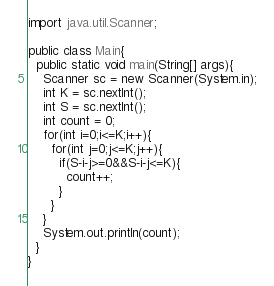<code> <loc_0><loc_0><loc_500><loc_500><_Java_>import java.util.Scanner;

public class Main{
  public static void main(String[] args){
    Scanner sc = new Scanner(System.in);
    int K = sc.nextInt();
    int S = sc.nextInt();
    int count = 0;
    for(int i=0;i<=K;i++){
      for(int j=0;j<=K;j++){
        if(S-i-j>=0&&S-i-j<=K){
          count++;
        }
      }
    }
    System.out.println(count);
  }
}</code> 